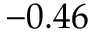<formula> <loc_0><loc_0><loc_500><loc_500>- 0 . 4 6</formula> 